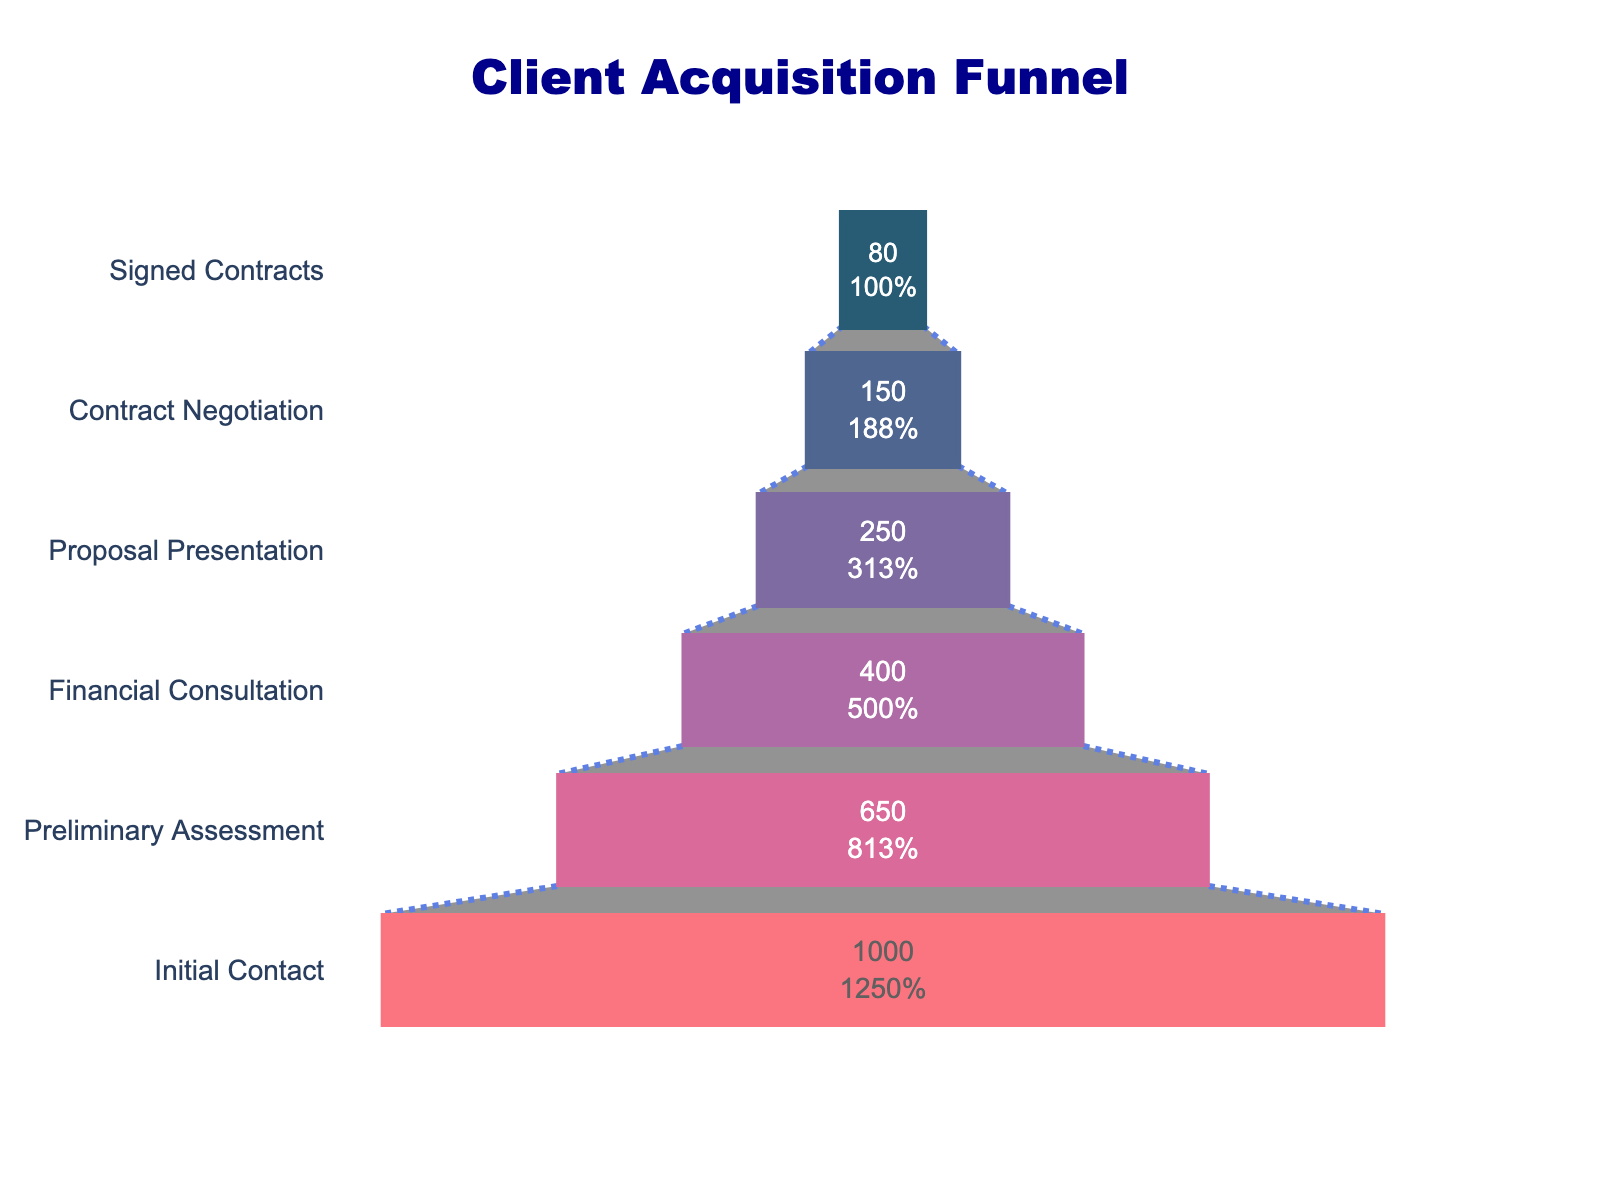What is the title of the figure? The title is prominently displayed at the top of the figure and is generally the first piece of text that catches the viewer's eye. In this case, it reads "Client Acquisition Funnel".
Answer: Client Acquisition Funnel How many prospects were initially contacted? The first stage in the funnel, labeled "Initial Contact," shows that there were 1000 prospects. This value is explicitly shown within the funnel graphic.
Answer: 1000 What percentage of prospects from the Preliminary Assessment stage moved on to the Financial Consultation stage? To find the percentage, we take the number of prospects that moved to the Financial Consultation stage (400) and divide it by the number of prospects from the Preliminary Assessment stage (650), then multiply by 100 for the percentage. (400/650) * 100 ≈ 61.54%.
Answer: approximately 61.54% Which stage has the largest drop in the number of prospects? To determine this, we compare the differences in the number of prospects between consecutive stages. The largest drop is between "Initial Contact" (1000) and "Preliminary Assessment" (650), which is a change of 350 prospects.
Answer: from Initial Contact to Preliminary Assessment What color is used to represent the Contract Negotiation stage? The Contract Negotiation stage is represented by the second lightest color in the gradient used in the funnel, which is a shade of pink (#d45087).
Answer: pink How many stages are represented in the funnel chart? By counting the distinct stages listed from top to bottom within the funnel, we see there are six stages.
Answer: six What is the total number of prospects that made it to the Proposal Presentation stage? Referring directly to the funnel chart, we see that the Proposal Presentation stage has a total of 250 prospects.
Answer: 250 What is the difference in the number of prospects between the Financial Consultation and Contract Negotiation stages? Subtract the number of prospects in the Contract Negotiation stage (150) from those in the Financial Consultation stage (400): 400 - 150 = 250.
Answer: 250 What percentage of initial contacts result in signed contracts? To find this percentage, we take the number of signed contracts (80) and divide it by the number of initial contacts (1000), then multiply by 100: (80/1000) * 100 = 8%.
Answer: 8% Which stage has a lower number of prospects, the Proposal Presentation stage or the Signed Contracts stage? By comparing the numbers, Proposal Presentation has 250 prospects while Signed Contracts has 80 prospects, making Signed Contracts the lower one.
Answer: Signed Contracts 